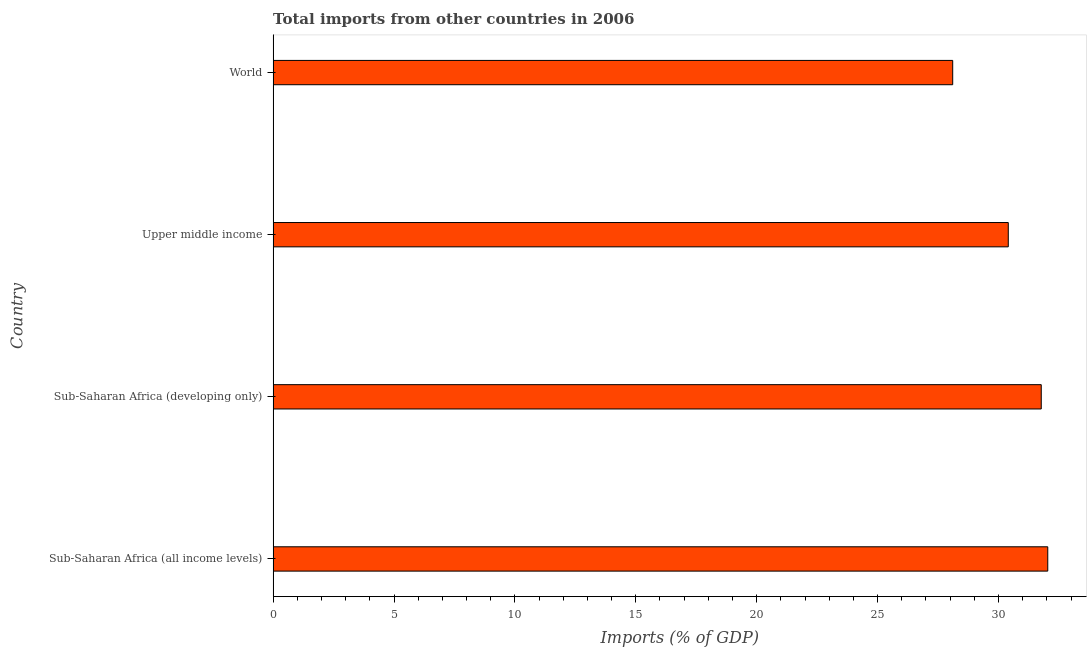Does the graph contain any zero values?
Offer a terse response. No. What is the title of the graph?
Offer a terse response. Total imports from other countries in 2006. What is the label or title of the X-axis?
Offer a very short reply. Imports (% of GDP). What is the label or title of the Y-axis?
Your answer should be very brief. Country. What is the total imports in Upper middle income?
Ensure brevity in your answer.  30.41. Across all countries, what is the maximum total imports?
Offer a very short reply. 32.04. Across all countries, what is the minimum total imports?
Your answer should be very brief. 28.11. In which country was the total imports maximum?
Your response must be concise. Sub-Saharan Africa (all income levels). In which country was the total imports minimum?
Make the answer very short. World. What is the sum of the total imports?
Your response must be concise. 122.32. What is the difference between the total imports in Sub-Saharan Africa (developing only) and World?
Give a very brief answer. 3.66. What is the average total imports per country?
Offer a terse response. 30.58. What is the median total imports?
Offer a very short reply. 31.09. In how many countries, is the total imports greater than 13 %?
Make the answer very short. 4. What is the ratio of the total imports in Sub-Saharan Africa (developing only) to that in Upper middle income?
Your answer should be compact. 1.04. What is the difference between the highest and the second highest total imports?
Keep it short and to the point. 0.27. What is the difference between the highest and the lowest total imports?
Provide a succinct answer. 3.93. In how many countries, is the total imports greater than the average total imports taken over all countries?
Make the answer very short. 2. Are all the bars in the graph horizontal?
Provide a succinct answer. Yes. How many countries are there in the graph?
Offer a terse response. 4. What is the Imports (% of GDP) in Sub-Saharan Africa (all income levels)?
Make the answer very short. 32.04. What is the Imports (% of GDP) in Sub-Saharan Africa (developing only)?
Your answer should be very brief. 31.77. What is the Imports (% of GDP) in Upper middle income?
Provide a short and direct response. 30.41. What is the Imports (% of GDP) in World?
Make the answer very short. 28.11. What is the difference between the Imports (% of GDP) in Sub-Saharan Africa (all income levels) and Sub-Saharan Africa (developing only)?
Provide a succinct answer. 0.27. What is the difference between the Imports (% of GDP) in Sub-Saharan Africa (all income levels) and Upper middle income?
Your response must be concise. 1.63. What is the difference between the Imports (% of GDP) in Sub-Saharan Africa (all income levels) and World?
Give a very brief answer. 3.93. What is the difference between the Imports (% of GDP) in Sub-Saharan Africa (developing only) and Upper middle income?
Offer a very short reply. 1.36. What is the difference between the Imports (% of GDP) in Sub-Saharan Africa (developing only) and World?
Provide a succinct answer. 3.66. What is the difference between the Imports (% of GDP) in Upper middle income and World?
Make the answer very short. 2.3. What is the ratio of the Imports (% of GDP) in Sub-Saharan Africa (all income levels) to that in Upper middle income?
Provide a succinct answer. 1.05. What is the ratio of the Imports (% of GDP) in Sub-Saharan Africa (all income levels) to that in World?
Keep it short and to the point. 1.14. What is the ratio of the Imports (% of GDP) in Sub-Saharan Africa (developing only) to that in Upper middle income?
Ensure brevity in your answer.  1.04. What is the ratio of the Imports (% of GDP) in Sub-Saharan Africa (developing only) to that in World?
Offer a terse response. 1.13. What is the ratio of the Imports (% of GDP) in Upper middle income to that in World?
Provide a succinct answer. 1.08. 